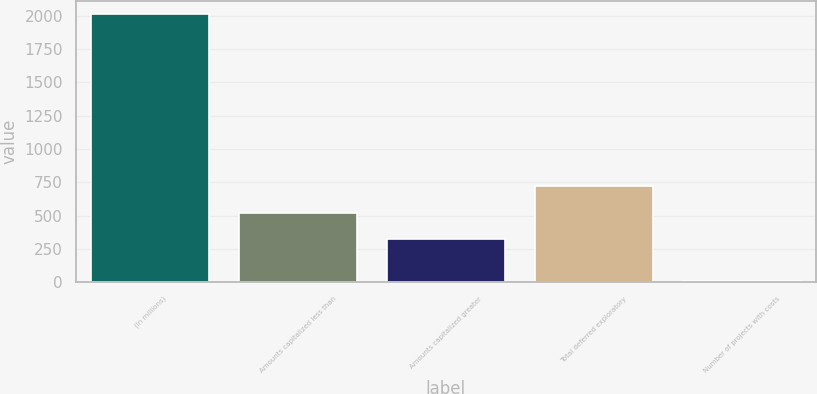Convert chart. <chart><loc_0><loc_0><loc_500><loc_500><bar_chart><fcel>(In millions)<fcel>Amounts capitalized less than<fcel>Amounts capitalized greater<fcel>Total deferred exploratory<fcel>Number of projects with costs<nl><fcel>2010<fcel>523.3<fcel>323<fcel>723.6<fcel>7<nl></chart> 